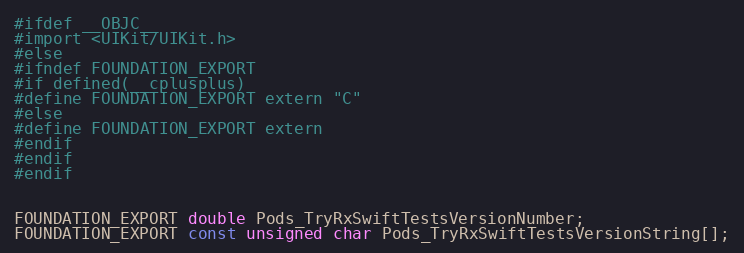<code> <loc_0><loc_0><loc_500><loc_500><_C_>#ifdef __OBJC__
#import <UIKit/UIKit.h>
#else
#ifndef FOUNDATION_EXPORT
#if defined(__cplusplus)
#define FOUNDATION_EXPORT extern "C"
#else
#define FOUNDATION_EXPORT extern
#endif
#endif
#endif


FOUNDATION_EXPORT double Pods_TryRxSwiftTestsVersionNumber;
FOUNDATION_EXPORT const unsigned char Pods_TryRxSwiftTestsVersionString[];

</code> 